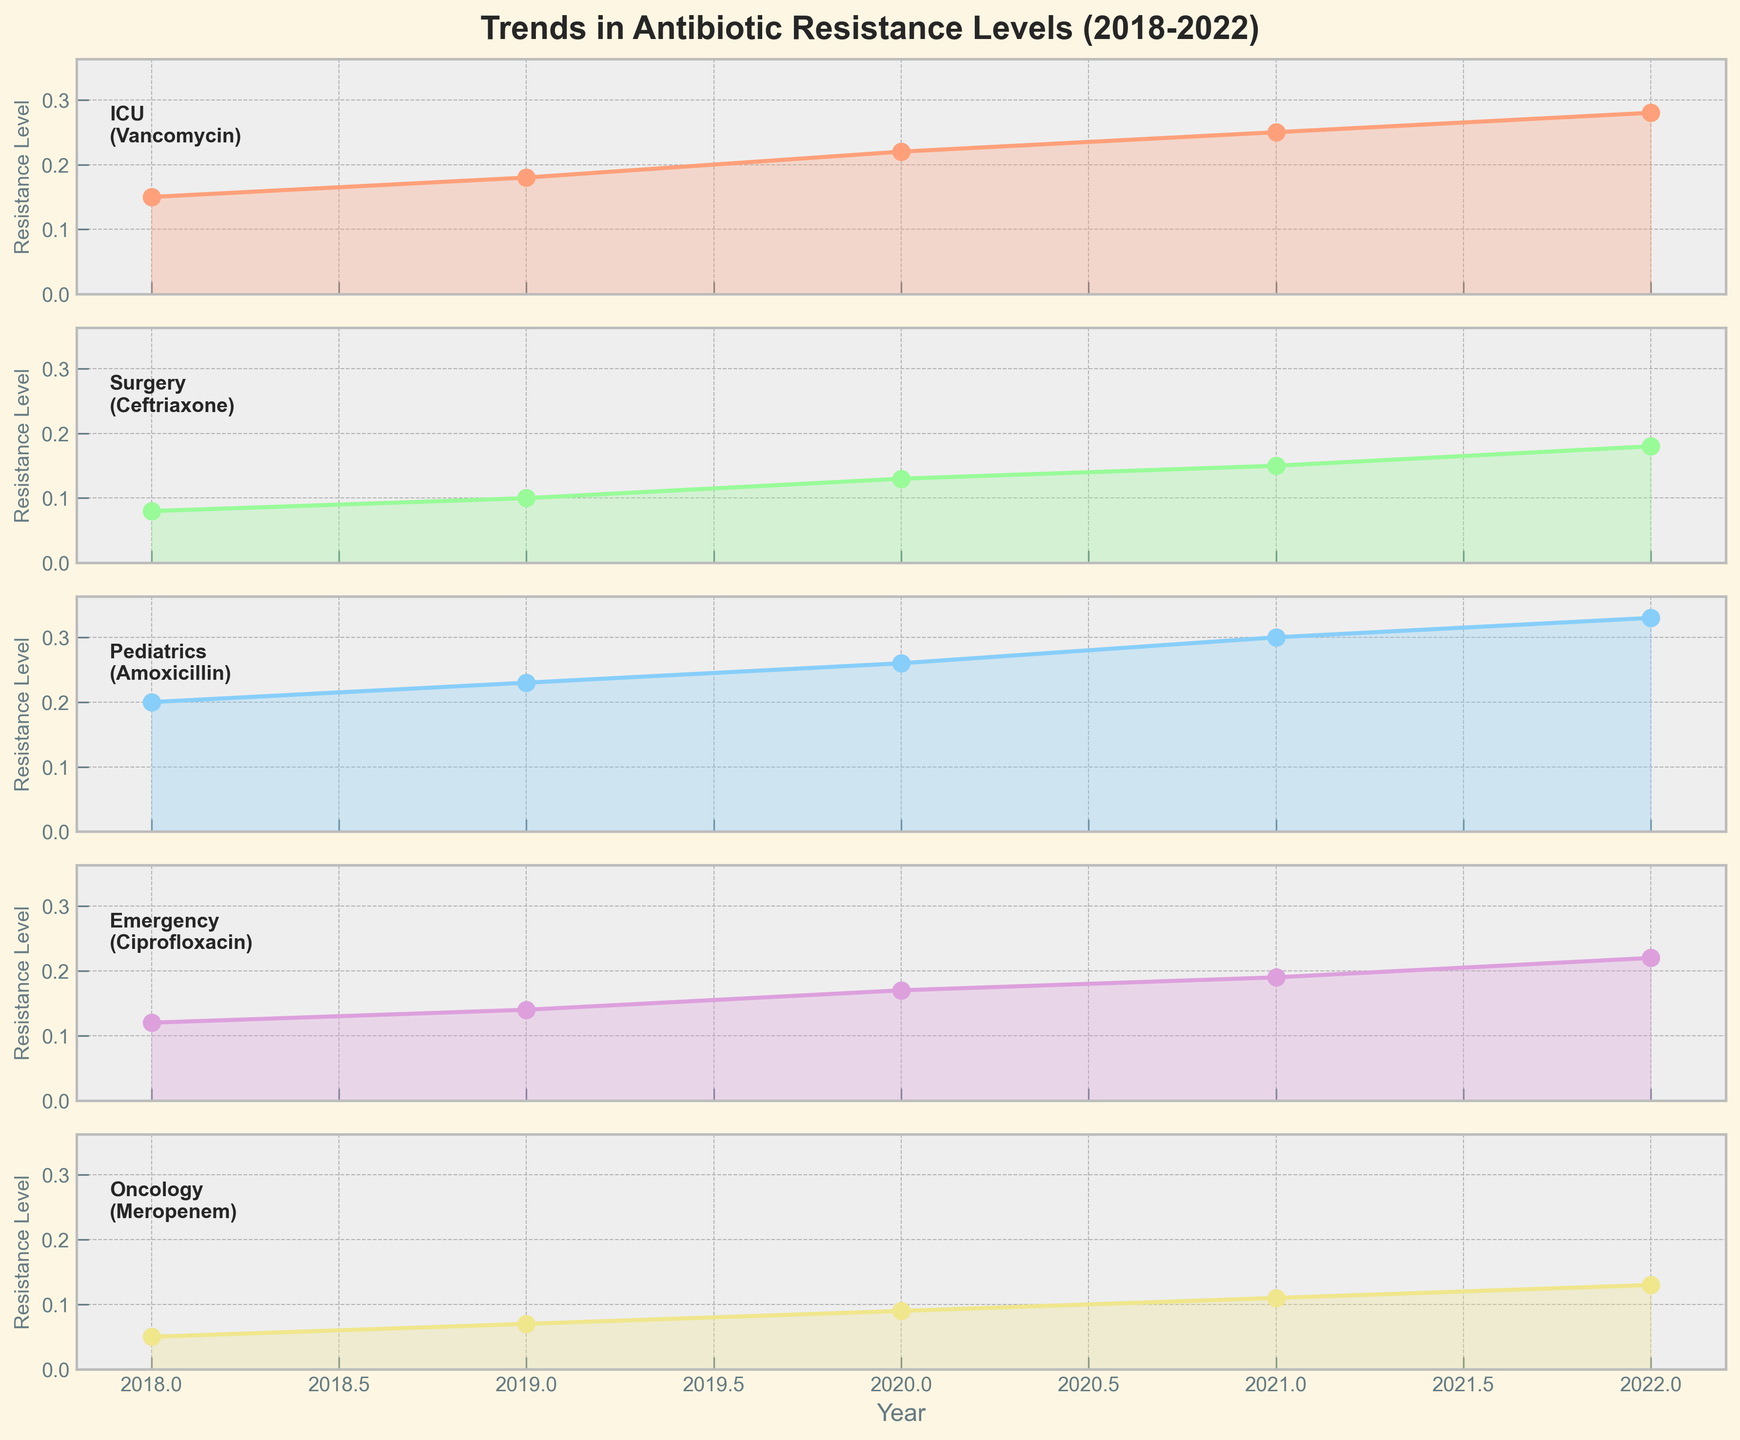What is the title of the plot? The title is typically located at the top of the plot and is usually in larger font size than the rest of the text. The title of the plot provides a brief descriptor of what the plot represents.
Answer: Trends in Antibiotic Resistance Levels (2018-2022) Which department shows the highest resistance level in 2022? To answer this, examine the resistance levels for each department plotted for the year 2022 and identify the highest value.
Answer: Pediatrics What antibiotic is being monitored in the Emergency department? Each subplot includes the department name and the antibiotic being monitored in that department, usually provided as a label or text annotation within the subplot.
Answer: Ciprofloxacin What is the overall trend observed for Vancomycin resistance in the ICU from 2018 to 2022? This requires looking at the line plot for Vancomycin in the ICU from 2018 to 2022, observing whether the resistance levels increase, decrease, or remain stable. The line shows an increasing trend.
Answer: Increasing Calculate the difference in resistance levels for Meropenem in Oncology between 2018 and 2022. To find the difference, subtract the resistance level for Meropenem in 2018 from the level in 2022. According to the plotted data: 0.13 (2022) - 0.05 (2018).
Answer: 0.08 Which department has the lowest baseline resistance level in 2018, and what is that level? Examine the resistance levels for each department in the year 2018 and find the lowest value.
Answer: Oncology, 0.05 Compare the rate of increase in resistance levels from 2018 to 2022 between Amoxicillin in Pediatrics and Ceftriaxone in Surgery. Calculate the increase in resistance levels over this period for both antibiotics, then compare the values. Pediatrics: 0.33 (2022) - 0.20 (2018) = 0.13, Surgery: 0.18 (2022) - 0.08 (2018) = 0.10.
Answer: Amoxicillin in Pediatrics increases faster than Ceftriaxone in Surgery What can be inferred about the resistance trends in ICU and Oncology departments? By examining the line plots for both departments, one can observe that the resistance levels in both departments show an increasing trend from 2018 to 2022.
Answer: Both departments show increasing resistance levels Are there any departments where the resistance level remains constant over any of the years? To determine this, check each department's line plot for any years where the resistance level does not change.
Answer: No Which antibiotic shows the lowest resistance level across all departments in 2022? Look at the resistance levels plotted for all departments in 2022 and identify the lowest value observed.
Answer: Meropenem 